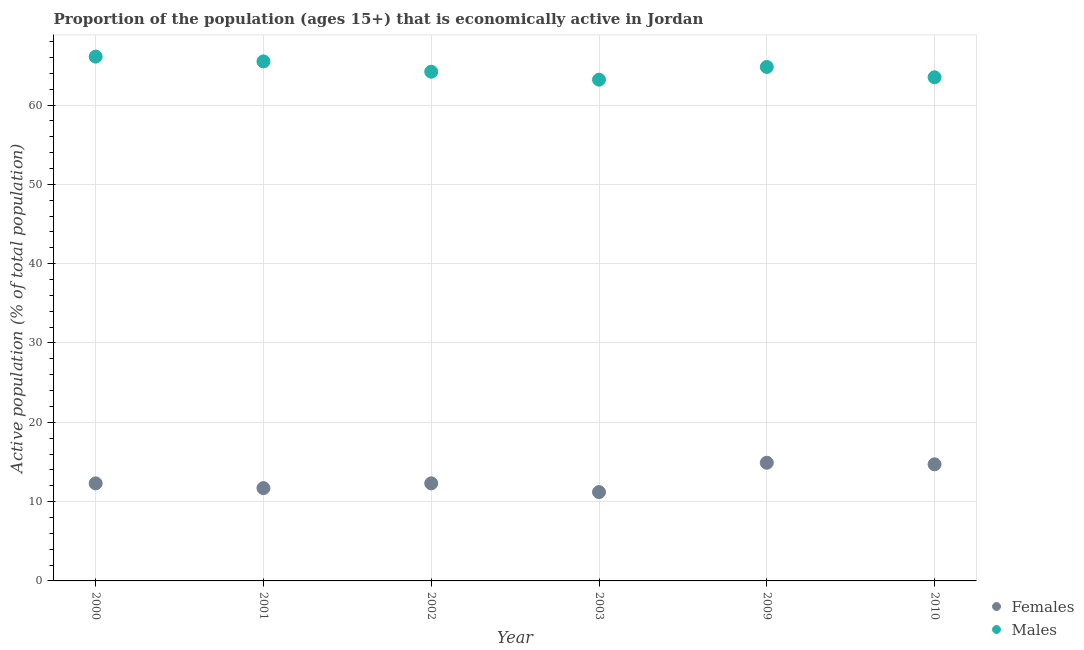Is the number of dotlines equal to the number of legend labels?
Provide a succinct answer. Yes. What is the percentage of economically active female population in 2009?
Your answer should be very brief. 14.9. Across all years, what is the maximum percentage of economically active female population?
Provide a succinct answer. 14.9. Across all years, what is the minimum percentage of economically active female population?
Your answer should be very brief. 11.2. In which year was the percentage of economically active male population maximum?
Your answer should be compact. 2000. In which year was the percentage of economically active male population minimum?
Make the answer very short. 2003. What is the total percentage of economically active male population in the graph?
Keep it short and to the point. 387.3. What is the difference between the percentage of economically active female population in 2001 and that in 2003?
Make the answer very short. 0.5. What is the difference between the percentage of economically active female population in 2003 and the percentage of economically active male population in 2009?
Your answer should be very brief. -53.6. What is the average percentage of economically active female population per year?
Your answer should be very brief. 12.85. In the year 2003, what is the difference between the percentage of economically active male population and percentage of economically active female population?
Give a very brief answer. 52. In how many years, is the percentage of economically active male population greater than 42 %?
Your answer should be very brief. 6. What is the ratio of the percentage of economically active male population in 2000 to that in 2010?
Ensure brevity in your answer.  1.04. What is the difference between the highest and the second highest percentage of economically active male population?
Your answer should be very brief. 0.6. What is the difference between the highest and the lowest percentage of economically active female population?
Provide a succinct answer. 3.7. Is the sum of the percentage of economically active female population in 2001 and 2002 greater than the maximum percentage of economically active male population across all years?
Ensure brevity in your answer.  No. Does the percentage of economically active female population monotonically increase over the years?
Provide a short and direct response. No. How many dotlines are there?
Give a very brief answer. 2. How many years are there in the graph?
Keep it short and to the point. 6. How many legend labels are there?
Provide a succinct answer. 2. How are the legend labels stacked?
Your answer should be very brief. Vertical. What is the title of the graph?
Keep it short and to the point. Proportion of the population (ages 15+) that is economically active in Jordan. Does "Official creditors" appear as one of the legend labels in the graph?
Make the answer very short. No. What is the label or title of the Y-axis?
Give a very brief answer. Active population (% of total population). What is the Active population (% of total population) in Females in 2000?
Your response must be concise. 12.3. What is the Active population (% of total population) in Males in 2000?
Give a very brief answer. 66.1. What is the Active population (% of total population) in Females in 2001?
Offer a terse response. 11.7. What is the Active population (% of total population) of Males in 2001?
Keep it short and to the point. 65.5. What is the Active population (% of total population) of Females in 2002?
Give a very brief answer. 12.3. What is the Active population (% of total population) of Males in 2002?
Your response must be concise. 64.2. What is the Active population (% of total population) in Females in 2003?
Your response must be concise. 11.2. What is the Active population (% of total population) of Males in 2003?
Your answer should be very brief. 63.2. What is the Active population (% of total population) of Females in 2009?
Your answer should be compact. 14.9. What is the Active population (% of total population) of Males in 2009?
Give a very brief answer. 64.8. What is the Active population (% of total population) of Females in 2010?
Give a very brief answer. 14.7. What is the Active population (% of total population) in Males in 2010?
Your answer should be very brief. 63.5. Across all years, what is the maximum Active population (% of total population) of Females?
Your response must be concise. 14.9. Across all years, what is the maximum Active population (% of total population) of Males?
Your answer should be compact. 66.1. Across all years, what is the minimum Active population (% of total population) in Females?
Provide a succinct answer. 11.2. Across all years, what is the minimum Active population (% of total population) in Males?
Offer a terse response. 63.2. What is the total Active population (% of total population) of Females in the graph?
Your answer should be compact. 77.1. What is the total Active population (% of total population) of Males in the graph?
Offer a very short reply. 387.3. What is the difference between the Active population (% of total population) in Females in 2000 and that in 2001?
Ensure brevity in your answer.  0.6. What is the difference between the Active population (% of total population) of Males in 2000 and that in 2001?
Your answer should be very brief. 0.6. What is the difference between the Active population (% of total population) in Females in 2000 and that in 2003?
Your answer should be very brief. 1.1. What is the difference between the Active population (% of total population) in Males in 2000 and that in 2010?
Offer a very short reply. 2.6. What is the difference between the Active population (% of total population) in Females in 2001 and that in 2002?
Offer a terse response. -0.6. What is the difference between the Active population (% of total population) of Females in 2001 and that in 2009?
Offer a terse response. -3.2. What is the difference between the Active population (% of total population) in Males in 2001 and that in 2010?
Your answer should be very brief. 2. What is the difference between the Active population (% of total population) of Males in 2002 and that in 2003?
Offer a terse response. 1. What is the difference between the Active population (% of total population) in Females in 2002 and that in 2009?
Offer a terse response. -2.6. What is the difference between the Active population (% of total population) in Females in 2002 and that in 2010?
Offer a very short reply. -2.4. What is the difference between the Active population (% of total population) in Females in 2003 and that in 2009?
Make the answer very short. -3.7. What is the difference between the Active population (% of total population) in Females in 2003 and that in 2010?
Give a very brief answer. -3.5. What is the difference between the Active population (% of total population) of Males in 2003 and that in 2010?
Offer a very short reply. -0.3. What is the difference between the Active population (% of total population) of Females in 2009 and that in 2010?
Your response must be concise. 0.2. What is the difference between the Active population (% of total population) in Females in 2000 and the Active population (% of total population) in Males in 2001?
Your response must be concise. -53.2. What is the difference between the Active population (% of total population) in Females in 2000 and the Active population (% of total population) in Males in 2002?
Offer a terse response. -51.9. What is the difference between the Active population (% of total population) in Females in 2000 and the Active population (% of total population) in Males in 2003?
Your answer should be compact. -50.9. What is the difference between the Active population (% of total population) of Females in 2000 and the Active population (% of total population) of Males in 2009?
Offer a very short reply. -52.5. What is the difference between the Active population (% of total population) in Females in 2000 and the Active population (% of total population) in Males in 2010?
Your answer should be very brief. -51.2. What is the difference between the Active population (% of total population) in Females in 2001 and the Active population (% of total population) in Males in 2002?
Give a very brief answer. -52.5. What is the difference between the Active population (% of total population) in Females in 2001 and the Active population (% of total population) in Males in 2003?
Your response must be concise. -51.5. What is the difference between the Active population (% of total population) in Females in 2001 and the Active population (% of total population) in Males in 2009?
Your answer should be very brief. -53.1. What is the difference between the Active population (% of total population) of Females in 2001 and the Active population (% of total population) of Males in 2010?
Offer a very short reply. -51.8. What is the difference between the Active population (% of total population) in Females in 2002 and the Active population (% of total population) in Males in 2003?
Offer a very short reply. -50.9. What is the difference between the Active population (% of total population) in Females in 2002 and the Active population (% of total population) in Males in 2009?
Your answer should be compact. -52.5. What is the difference between the Active population (% of total population) in Females in 2002 and the Active population (% of total population) in Males in 2010?
Make the answer very short. -51.2. What is the difference between the Active population (% of total population) in Females in 2003 and the Active population (% of total population) in Males in 2009?
Make the answer very short. -53.6. What is the difference between the Active population (% of total population) of Females in 2003 and the Active population (% of total population) of Males in 2010?
Give a very brief answer. -52.3. What is the difference between the Active population (% of total population) of Females in 2009 and the Active population (% of total population) of Males in 2010?
Your response must be concise. -48.6. What is the average Active population (% of total population) in Females per year?
Ensure brevity in your answer.  12.85. What is the average Active population (% of total population) in Males per year?
Offer a terse response. 64.55. In the year 2000, what is the difference between the Active population (% of total population) in Females and Active population (% of total population) in Males?
Make the answer very short. -53.8. In the year 2001, what is the difference between the Active population (% of total population) in Females and Active population (% of total population) in Males?
Your response must be concise. -53.8. In the year 2002, what is the difference between the Active population (% of total population) of Females and Active population (% of total population) of Males?
Offer a very short reply. -51.9. In the year 2003, what is the difference between the Active population (% of total population) of Females and Active population (% of total population) of Males?
Your answer should be compact. -52. In the year 2009, what is the difference between the Active population (% of total population) in Females and Active population (% of total population) in Males?
Ensure brevity in your answer.  -49.9. In the year 2010, what is the difference between the Active population (% of total population) in Females and Active population (% of total population) in Males?
Offer a very short reply. -48.8. What is the ratio of the Active population (% of total population) in Females in 2000 to that in 2001?
Your answer should be compact. 1.05. What is the ratio of the Active population (% of total population) of Males in 2000 to that in 2001?
Keep it short and to the point. 1.01. What is the ratio of the Active population (% of total population) in Females in 2000 to that in 2002?
Give a very brief answer. 1. What is the ratio of the Active population (% of total population) in Males in 2000 to that in 2002?
Ensure brevity in your answer.  1.03. What is the ratio of the Active population (% of total population) of Females in 2000 to that in 2003?
Make the answer very short. 1.1. What is the ratio of the Active population (% of total population) in Males in 2000 to that in 2003?
Make the answer very short. 1.05. What is the ratio of the Active population (% of total population) of Females in 2000 to that in 2009?
Give a very brief answer. 0.83. What is the ratio of the Active population (% of total population) of Males in 2000 to that in 2009?
Provide a short and direct response. 1.02. What is the ratio of the Active population (% of total population) of Females in 2000 to that in 2010?
Your answer should be very brief. 0.84. What is the ratio of the Active population (% of total population) of Males in 2000 to that in 2010?
Give a very brief answer. 1.04. What is the ratio of the Active population (% of total population) of Females in 2001 to that in 2002?
Offer a terse response. 0.95. What is the ratio of the Active population (% of total population) in Males in 2001 to that in 2002?
Offer a terse response. 1.02. What is the ratio of the Active population (% of total population) in Females in 2001 to that in 2003?
Offer a very short reply. 1.04. What is the ratio of the Active population (% of total population) in Males in 2001 to that in 2003?
Give a very brief answer. 1.04. What is the ratio of the Active population (% of total population) of Females in 2001 to that in 2009?
Your response must be concise. 0.79. What is the ratio of the Active population (% of total population) in Males in 2001 to that in 2009?
Give a very brief answer. 1.01. What is the ratio of the Active population (% of total population) in Females in 2001 to that in 2010?
Keep it short and to the point. 0.8. What is the ratio of the Active population (% of total population) of Males in 2001 to that in 2010?
Your answer should be very brief. 1.03. What is the ratio of the Active population (% of total population) of Females in 2002 to that in 2003?
Your answer should be very brief. 1.1. What is the ratio of the Active population (% of total population) in Males in 2002 to that in 2003?
Your answer should be very brief. 1.02. What is the ratio of the Active population (% of total population) of Females in 2002 to that in 2009?
Offer a very short reply. 0.83. What is the ratio of the Active population (% of total population) in Females in 2002 to that in 2010?
Offer a terse response. 0.84. What is the ratio of the Active population (% of total population) of Males in 2002 to that in 2010?
Your answer should be very brief. 1.01. What is the ratio of the Active population (% of total population) in Females in 2003 to that in 2009?
Your response must be concise. 0.75. What is the ratio of the Active population (% of total population) of Males in 2003 to that in 2009?
Your answer should be compact. 0.98. What is the ratio of the Active population (% of total population) of Females in 2003 to that in 2010?
Your response must be concise. 0.76. What is the ratio of the Active population (% of total population) of Females in 2009 to that in 2010?
Make the answer very short. 1.01. What is the ratio of the Active population (% of total population) in Males in 2009 to that in 2010?
Keep it short and to the point. 1.02. What is the difference between the highest and the second highest Active population (% of total population) in Females?
Make the answer very short. 0.2. What is the difference between the highest and the second highest Active population (% of total population) in Males?
Your answer should be compact. 0.6. 